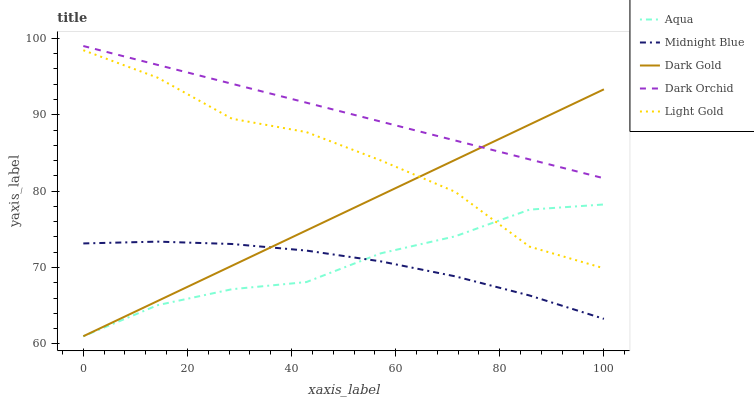Does Midnight Blue have the minimum area under the curve?
Answer yes or no. Yes. Does Dark Orchid have the maximum area under the curve?
Answer yes or no. Yes. Does Aqua have the minimum area under the curve?
Answer yes or no. No. Does Aqua have the maximum area under the curve?
Answer yes or no. No. Is Dark Orchid the smoothest?
Answer yes or no. Yes. Is Light Gold the roughest?
Answer yes or no. Yes. Is Aqua the smoothest?
Answer yes or no. No. Is Aqua the roughest?
Answer yes or no. No. Does Aqua have the lowest value?
Answer yes or no. Yes. Does Midnight Blue have the lowest value?
Answer yes or no. No. Does Dark Orchid have the highest value?
Answer yes or no. Yes. Does Aqua have the highest value?
Answer yes or no. No. Is Aqua less than Dark Orchid?
Answer yes or no. Yes. Is Dark Orchid greater than Aqua?
Answer yes or no. Yes. Does Dark Gold intersect Midnight Blue?
Answer yes or no. Yes. Is Dark Gold less than Midnight Blue?
Answer yes or no. No. Is Dark Gold greater than Midnight Blue?
Answer yes or no. No. Does Aqua intersect Dark Orchid?
Answer yes or no. No. 